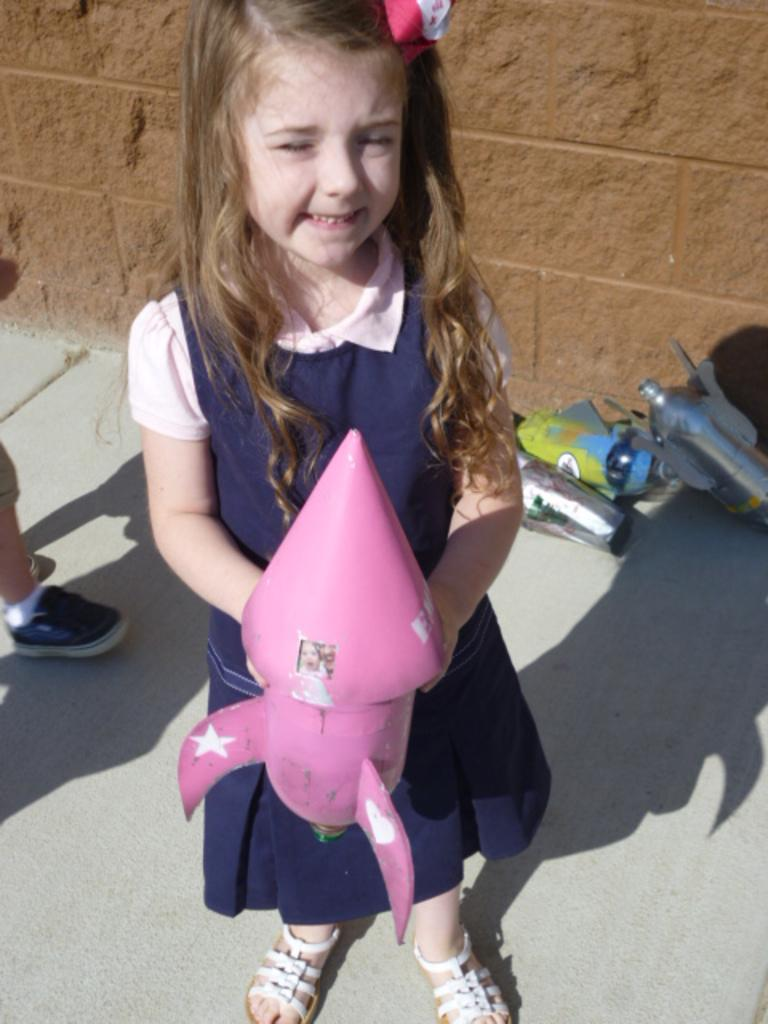What is the girl in the image doing? The girl is standing in the image, holding a rocket toy in her hand. What else can be seen on the ground in the image? There are other toys on the ground in the image. What is visible in the background of the image? There is a wall visible in the image. What type of quiver is the girl using to store her toys in the image? There is no quiver present in the image; the girl is holding a rocket toy in her hand and there are other toys on the ground. 